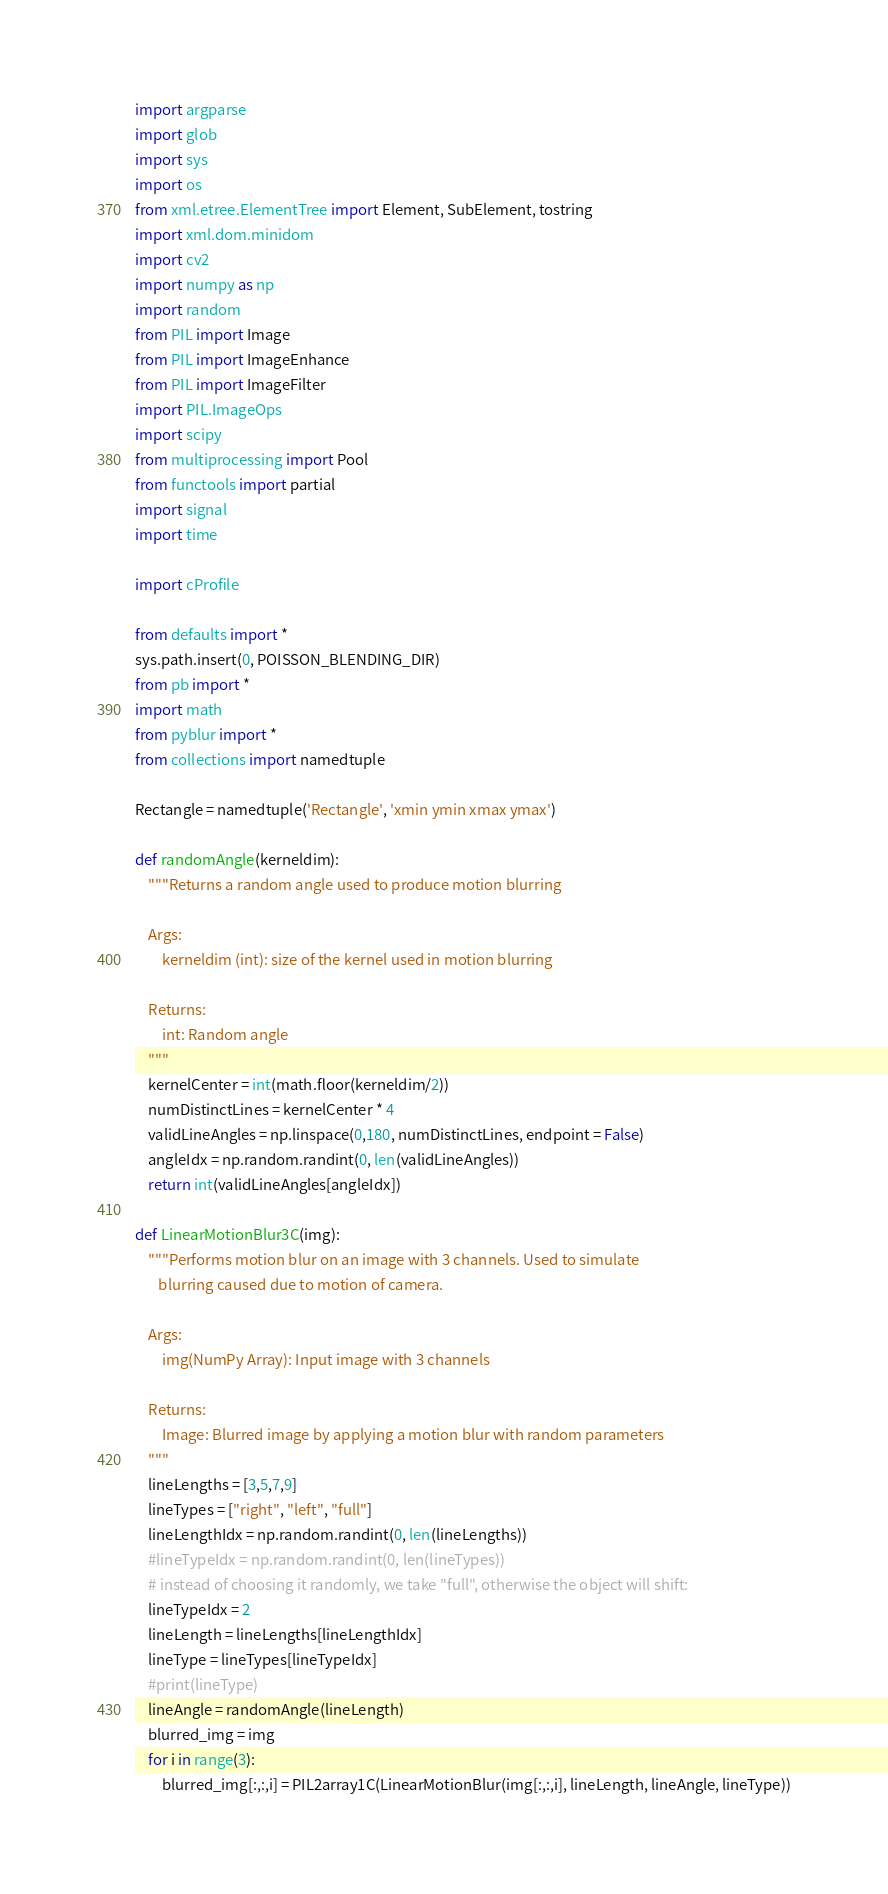<code> <loc_0><loc_0><loc_500><loc_500><_Python_>import argparse
import glob
import sys
import os
from xml.etree.ElementTree import Element, SubElement, tostring
import xml.dom.minidom
import cv2
import numpy as np
import random
from PIL import Image
from PIL import ImageEnhance
from PIL import ImageFilter
import PIL.ImageOps    
import scipy
from multiprocessing import Pool
from functools import partial
import signal
import time

import cProfile

from defaults import *
sys.path.insert(0, POISSON_BLENDING_DIR)
from pb import *
import math
from pyblur import *
from collections import namedtuple

Rectangle = namedtuple('Rectangle', 'xmin ymin xmax ymax')

def randomAngle(kerneldim):
    """Returns a random angle used to produce motion blurring

    Args:
        kerneldim (int): size of the kernel used in motion blurring

    Returns:
        int: Random angle
    """ 
    kernelCenter = int(math.floor(kerneldim/2))
    numDistinctLines = kernelCenter * 4
    validLineAngles = np.linspace(0,180, numDistinctLines, endpoint = False)
    angleIdx = np.random.randint(0, len(validLineAngles))
    return int(validLineAngles[angleIdx])

def LinearMotionBlur3C(img):
    """Performs motion blur on an image with 3 channels. Used to simulate 
       blurring caused due to motion of camera.

    Args:
        img(NumPy Array): Input image with 3 channels

    Returns:
        Image: Blurred image by applying a motion blur with random parameters
    """
    lineLengths = [3,5,7,9]
    lineTypes = ["right", "left", "full"]
    lineLengthIdx = np.random.randint(0, len(lineLengths))
    #lineTypeIdx = np.random.randint(0, len(lineTypes))
    # instead of choosing it randomly, we take "full", otherwise the object will shift:
    lineTypeIdx = 2
    lineLength = lineLengths[lineLengthIdx]
    lineType = lineTypes[lineTypeIdx]
    #print(lineType)
    lineAngle = randomAngle(lineLength)
    blurred_img = img
    for i in range(3):
        blurred_img[:,:,i] = PIL2array1C(LinearMotionBlur(img[:,:,i], lineLength, lineAngle, lineType))</code> 